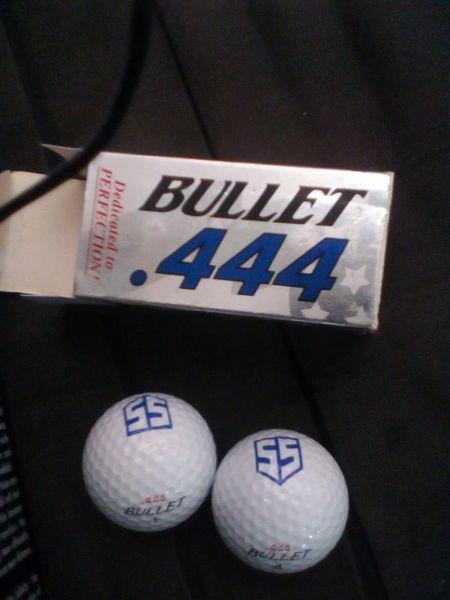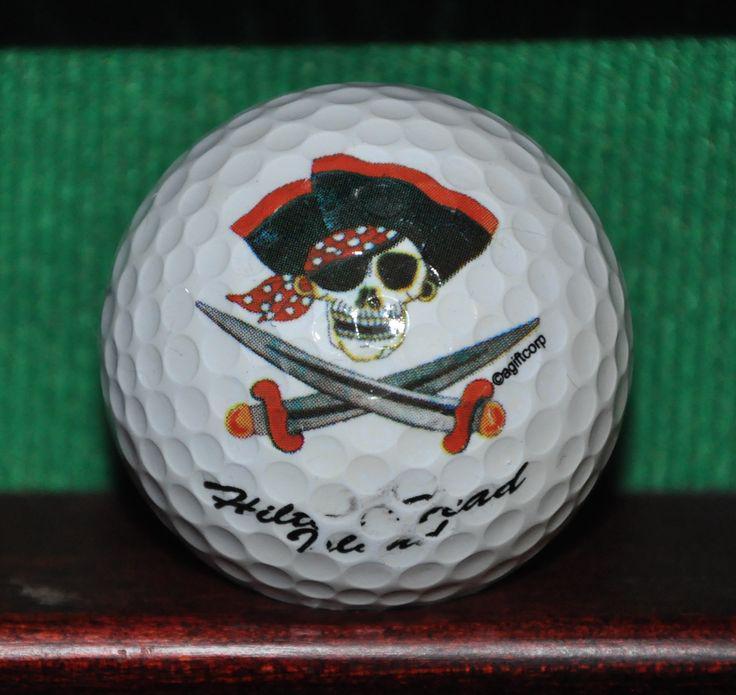The first image is the image on the left, the second image is the image on the right. For the images shown, is this caption "In the image to the right the golfball has a design that is square shaped." true? Answer yes or no. No. 